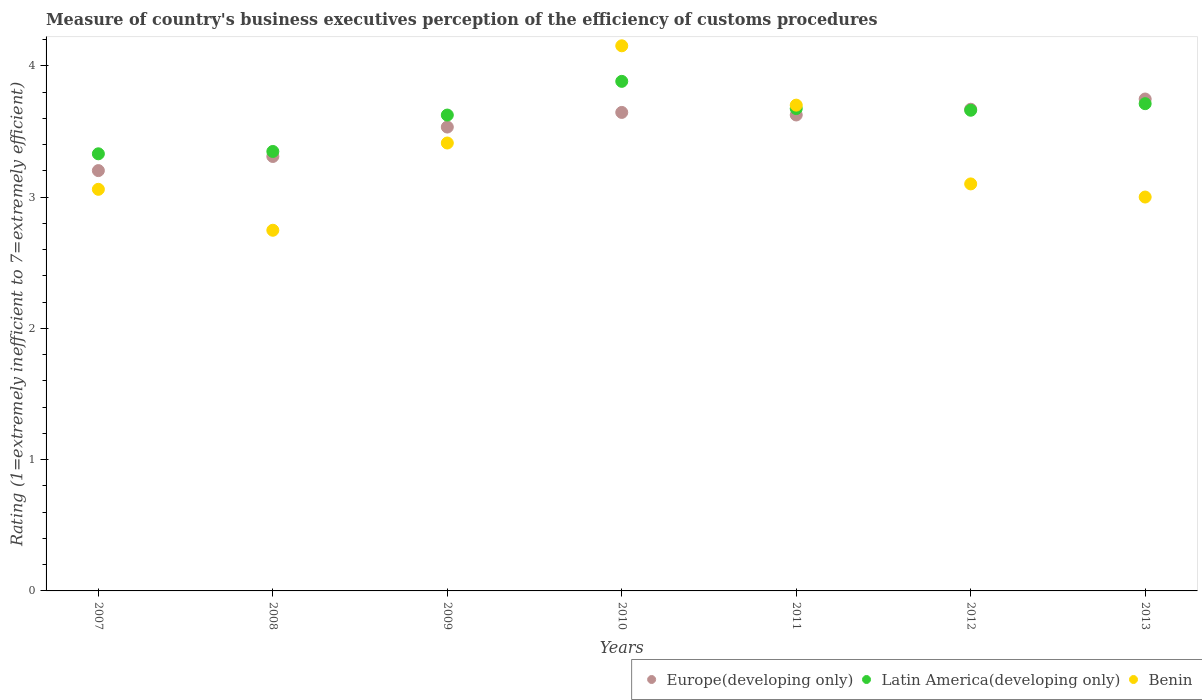How many different coloured dotlines are there?
Your answer should be compact. 3. Is the number of dotlines equal to the number of legend labels?
Give a very brief answer. Yes. What is the rating of the efficiency of customs procedure in Latin America(developing only) in 2013?
Provide a short and direct response. 3.71. Across all years, what is the maximum rating of the efficiency of customs procedure in Europe(developing only)?
Keep it short and to the point. 3.75. Across all years, what is the minimum rating of the efficiency of customs procedure in Benin?
Give a very brief answer. 2.75. In which year was the rating of the efficiency of customs procedure in Europe(developing only) maximum?
Ensure brevity in your answer.  2013. What is the total rating of the efficiency of customs procedure in Benin in the graph?
Your answer should be compact. 23.17. What is the difference between the rating of the efficiency of customs procedure in Europe(developing only) in 2010 and that in 2011?
Ensure brevity in your answer.  0.02. What is the difference between the rating of the efficiency of customs procedure in Latin America(developing only) in 2007 and the rating of the efficiency of customs procedure in Benin in 2012?
Provide a succinct answer. 0.23. What is the average rating of the efficiency of customs procedure in Benin per year?
Your answer should be very brief. 3.31. In the year 2013, what is the difference between the rating of the efficiency of customs procedure in Latin America(developing only) and rating of the efficiency of customs procedure in Europe(developing only)?
Give a very brief answer. -0.04. What is the ratio of the rating of the efficiency of customs procedure in Europe(developing only) in 2011 to that in 2012?
Give a very brief answer. 0.99. Is the rating of the efficiency of customs procedure in Europe(developing only) in 2009 less than that in 2012?
Offer a terse response. Yes. Is the difference between the rating of the efficiency of customs procedure in Latin America(developing only) in 2007 and 2009 greater than the difference between the rating of the efficiency of customs procedure in Europe(developing only) in 2007 and 2009?
Offer a terse response. Yes. What is the difference between the highest and the second highest rating of the efficiency of customs procedure in Latin America(developing only)?
Provide a succinct answer. 0.17. What is the difference between the highest and the lowest rating of the efficiency of customs procedure in Latin America(developing only)?
Your response must be concise. 0.55. In how many years, is the rating of the efficiency of customs procedure in Europe(developing only) greater than the average rating of the efficiency of customs procedure in Europe(developing only) taken over all years?
Provide a succinct answer. 5. Is the sum of the rating of the efficiency of customs procedure in Latin America(developing only) in 2007 and 2012 greater than the maximum rating of the efficiency of customs procedure in Benin across all years?
Your response must be concise. Yes. Is it the case that in every year, the sum of the rating of the efficiency of customs procedure in Benin and rating of the efficiency of customs procedure in Latin America(developing only)  is greater than the rating of the efficiency of customs procedure in Europe(developing only)?
Provide a short and direct response. Yes. How many dotlines are there?
Give a very brief answer. 3. How many years are there in the graph?
Ensure brevity in your answer.  7. Are the values on the major ticks of Y-axis written in scientific E-notation?
Your answer should be very brief. No. Does the graph contain any zero values?
Make the answer very short. No. How are the legend labels stacked?
Provide a succinct answer. Horizontal. What is the title of the graph?
Make the answer very short. Measure of country's business executives perception of the efficiency of customs procedures. Does "Grenada" appear as one of the legend labels in the graph?
Offer a terse response. No. What is the label or title of the Y-axis?
Keep it short and to the point. Rating (1=extremely inefficient to 7=extremely efficient). What is the Rating (1=extremely inefficient to 7=extremely efficient) in Europe(developing only) in 2007?
Your answer should be compact. 3.2. What is the Rating (1=extremely inefficient to 7=extremely efficient) of Latin America(developing only) in 2007?
Your answer should be very brief. 3.33. What is the Rating (1=extremely inefficient to 7=extremely efficient) of Benin in 2007?
Offer a very short reply. 3.06. What is the Rating (1=extremely inefficient to 7=extremely efficient) of Europe(developing only) in 2008?
Give a very brief answer. 3.31. What is the Rating (1=extremely inefficient to 7=extremely efficient) in Latin America(developing only) in 2008?
Your answer should be very brief. 3.35. What is the Rating (1=extremely inefficient to 7=extremely efficient) of Benin in 2008?
Offer a very short reply. 2.75. What is the Rating (1=extremely inefficient to 7=extremely efficient) of Europe(developing only) in 2009?
Offer a terse response. 3.53. What is the Rating (1=extremely inefficient to 7=extremely efficient) of Latin America(developing only) in 2009?
Provide a short and direct response. 3.62. What is the Rating (1=extremely inefficient to 7=extremely efficient) of Benin in 2009?
Offer a terse response. 3.41. What is the Rating (1=extremely inefficient to 7=extremely efficient) of Europe(developing only) in 2010?
Make the answer very short. 3.64. What is the Rating (1=extremely inefficient to 7=extremely efficient) in Latin America(developing only) in 2010?
Offer a terse response. 3.88. What is the Rating (1=extremely inefficient to 7=extremely efficient) in Benin in 2010?
Offer a terse response. 4.15. What is the Rating (1=extremely inefficient to 7=extremely efficient) in Europe(developing only) in 2011?
Offer a very short reply. 3.62. What is the Rating (1=extremely inefficient to 7=extremely efficient) in Latin America(developing only) in 2011?
Your answer should be compact. 3.67. What is the Rating (1=extremely inefficient to 7=extremely efficient) of Benin in 2011?
Ensure brevity in your answer.  3.7. What is the Rating (1=extremely inefficient to 7=extremely efficient) in Europe(developing only) in 2012?
Provide a succinct answer. 3.67. What is the Rating (1=extremely inefficient to 7=extremely efficient) in Latin America(developing only) in 2012?
Provide a succinct answer. 3.66. What is the Rating (1=extremely inefficient to 7=extremely efficient) of Benin in 2012?
Ensure brevity in your answer.  3.1. What is the Rating (1=extremely inefficient to 7=extremely efficient) in Europe(developing only) in 2013?
Keep it short and to the point. 3.75. What is the Rating (1=extremely inefficient to 7=extremely efficient) in Latin America(developing only) in 2013?
Offer a very short reply. 3.71. What is the Rating (1=extremely inefficient to 7=extremely efficient) of Benin in 2013?
Offer a terse response. 3. Across all years, what is the maximum Rating (1=extremely inefficient to 7=extremely efficient) in Europe(developing only)?
Make the answer very short. 3.75. Across all years, what is the maximum Rating (1=extremely inefficient to 7=extremely efficient) in Latin America(developing only)?
Give a very brief answer. 3.88. Across all years, what is the maximum Rating (1=extremely inefficient to 7=extremely efficient) of Benin?
Your answer should be compact. 4.15. Across all years, what is the minimum Rating (1=extremely inefficient to 7=extremely efficient) in Europe(developing only)?
Give a very brief answer. 3.2. Across all years, what is the minimum Rating (1=extremely inefficient to 7=extremely efficient) of Latin America(developing only)?
Keep it short and to the point. 3.33. Across all years, what is the minimum Rating (1=extremely inefficient to 7=extremely efficient) in Benin?
Offer a very short reply. 2.75. What is the total Rating (1=extremely inefficient to 7=extremely efficient) in Europe(developing only) in the graph?
Give a very brief answer. 24.73. What is the total Rating (1=extremely inefficient to 7=extremely efficient) in Latin America(developing only) in the graph?
Keep it short and to the point. 25.23. What is the total Rating (1=extremely inefficient to 7=extremely efficient) in Benin in the graph?
Provide a short and direct response. 23.17. What is the difference between the Rating (1=extremely inefficient to 7=extremely efficient) in Europe(developing only) in 2007 and that in 2008?
Make the answer very short. -0.11. What is the difference between the Rating (1=extremely inefficient to 7=extremely efficient) in Latin America(developing only) in 2007 and that in 2008?
Keep it short and to the point. -0.02. What is the difference between the Rating (1=extremely inefficient to 7=extremely efficient) of Benin in 2007 and that in 2008?
Provide a succinct answer. 0.31. What is the difference between the Rating (1=extremely inefficient to 7=extremely efficient) in Europe(developing only) in 2007 and that in 2009?
Ensure brevity in your answer.  -0.33. What is the difference between the Rating (1=extremely inefficient to 7=extremely efficient) of Latin America(developing only) in 2007 and that in 2009?
Your answer should be very brief. -0.3. What is the difference between the Rating (1=extremely inefficient to 7=extremely efficient) in Benin in 2007 and that in 2009?
Ensure brevity in your answer.  -0.35. What is the difference between the Rating (1=extremely inefficient to 7=extremely efficient) of Europe(developing only) in 2007 and that in 2010?
Make the answer very short. -0.44. What is the difference between the Rating (1=extremely inefficient to 7=extremely efficient) in Latin America(developing only) in 2007 and that in 2010?
Your answer should be very brief. -0.55. What is the difference between the Rating (1=extremely inefficient to 7=extremely efficient) in Benin in 2007 and that in 2010?
Make the answer very short. -1.09. What is the difference between the Rating (1=extremely inefficient to 7=extremely efficient) in Europe(developing only) in 2007 and that in 2011?
Make the answer very short. -0.42. What is the difference between the Rating (1=extremely inefficient to 7=extremely efficient) in Latin America(developing only) in 2007 and that in 2011?
Provide a succinct answer. -0.34. What is the difference between the Rating (1=extremely inefficient to 7=extremely efficient) in Benin in 2007 and that in 2011?
Ensure brevity in your answer.  -0.64. What is the difference between the Rating (1=extremely inefficient to 7=extremely efficient) of Europe(developing only) in 2007 and that in 2012?
Make the answer very short. -0.47. What is the difference between the Rating (1=extremely inefficient to 7=extremely efficient) in Latin America(developing only) in 2007 and that in 2012?
Provide a short and direct response. -0.33. What is the difference between the Rating (1=extremely inefficient to 7=extremely efficient) in Benin in 2007 and that in 2012?
Your response must be concise. -0.04. What is the difference between the Rating (1=extremely inefficient to 7=extremely efficient) in Europe(developing only) in 2007 and that in 2013?
Your answer should be compact. -0.55. What is the difference between the Rating (1=extremely inefficient to 7=extremely efficient) in Latin America(developing only) in 2007 and that in 2013?
Keep it short and to the point. -0.38. What is the difference between the Rating (1=extremely inefficient to 7=extremely efficient) of Benin in 2007 and that in 2013?
Provide a short and direct response. 0.06. What is the difference between the Rating (1=extremely inefficient to 7=extremely efficient) in Europe(developing only) in 2008 and that in 2009?
Give a very brief answer. -0.22. What is the difference between the Rating (1=extremely inefficient to 7=extremely efficient) of Latin America(developing only) in 2008 and that in 2009?
Your answer should be very brief. -0.28. What is the difference between the Rating (1=extremely inefficient to 7=extremely efficient) in Benin in 2008 and that in 2009?
Your response must be concise. -0.66. What is the difference between the Rating (1=extremely inefficient to 7=extremely efficient) in Europe(developing only) in 2008 and that in 2010?
Offer a terse response. -0.34. What is the difference between the Rating (1=extremely inefficient to 7=extremely efficient) of Latin America(developing only) in 2008 and that in 2010?
Provide a short and direct response. -0.53. What is the difference between the Rating (1=extremely inefficient to 7=extremely efficient) in Benin in 2008 and that in 2010?
Give a very brief answer. -1.41. What is the difference between the Rating (1=extremely inefficient to 7=extremely efficient) of Europe(developing only) in 2008 and that in 2011?
Your answer should be compact. -0.32. What is the difference between the Rating (1=extremely inefficient to 7=extremely efficient) of Latin America(developing only) in 2008 and that in 2011?
Provide a short and direct response. -0.33. What is the difference between the Rating (1=extremely inefficient to 7=extremely efficient) in Benin in 2008 and that in 2011?
Offer a terse response. -0.95. What is the difference between the Rating (1=extremely inefficient to 7=extremely efficient) of Europe(developing only) in 2008 and that in 2012?
Give a very brief answer. -0.36. What is the difference between the Rating (1=extremely inefficient to 7=extremely efficient) of Latin America(developing only) in 2008 and that in 2012?
Your response must be concise. -0.31. What is the difference between the Rating (1=extremely inefficient to 7=extremely efficient) of Benin in 2008 and that in 2012?
Keep it short and to the point. -0.35. What is the difference between the Rating (1=extremely inefficient to 7=extremely efficient) of Europe(developing only) in 2008 and that in 2013?
Ensure brevity in your answer.  -0.44. What is the difference between the Rating (1=extremely inefficient to 7=extremely efficient) in Latin America(developing only) in 2008 and that in 2013?
Provide a short and direct response. -0.36. What is the difference between the Rating (1=extremely inefficient to 7=extremely efficient) of Benin in 2008 and that in 2013?
Provide a short and direct response. -0.25. What is the difference between the Rating (1=extremely inefficient to 7=extremely efficient) in Europe(developing only) in 2009 and that in 2010?
Your answer should be very brief. -0.11. What is the difference between the Rating (1=extremely inefficient to 7=extremely efficient) of Latin America(developing only) in 2009 and that in 2010?
Ensure brevity in your answer.  -0.26. What is the difference between the Rating (1=extremely inefficient to 7=extremely efficient) of Benin in 2009 and that in 2010?
Your response must be concise. -0.74. What is the difference between the Rating (1=extremely inefficient to 7=extremely efficient) in Europe(developing only) in 2009 and that in 2011?
Your answer should be compact. -0.09. What is the difference between the Rating (1=extremely inefficient to 7=extremely efficient) of Latin America(developing only) in 2009 and that in 2011?
Your answer should be very brief. -0.05. What is the difference between the Rating (1=extremely inefficient to 7=extremely efficient) of Benin in 2009 and that in 2011?
Keep it short and to the point. -0.29. What is the difference between the Rating (1=extremely inefficient to 7=extremely efficient) of Europe(developing only) in 2009 and that in 2012?
Your answer should be very brief. -0.14. What is the difference between the Rating (1=extremely inefficient to 7=extremely efficient) in Latin America(developing only) in 2009 and that in 2012?
Your response must be concise. -0.04. What is the difference between the Rating (1=extremely inefficient to 7=extremely efficient) in Benin in 2009 and that in 2012?
Your response must be concise. 0.31. What is the difference between the Rating (1=extremely inefficient to 7=extremely efficient) of Europe(developing only) in 2009 and that in 2013?
Keep it short and to the point. -0.21. What is the difference between the Rating (1=extremely inefficient to 7=extremely efficient) of Latin America(developing only) in 2009 and that in 2013?
Provide a short and direct response. -0.09. What is the difference between the Rating (1=extremely inefficient to 7=extremely efficient) of Benin in 2009 and that in 2013?
Offer a terse response. 0.41. What is the difference between the Rating (1=extremely inefficient to 7=extremely efficient) in Europe(developing only) in 2010 and that in 2011?
Your response must be concise. 0.02. What is the difference between the Rating (1=extremely inefficient to 7=extremely efficient) in Latin America(developing only) in 2010 and that in 2011?
Give a very brief answer. 0.21. What is the difference between the Rating (1=extremely inefficient to 7=extremely efficient) in Benin in 2010 and that in 2011?
Ensure brevity in your answer.  0.45. What is the difference between the Rating (1=extremely inefficient to 7=extremely efficient) in Europe(developing only) in 2010 and that in 2012?
Ensure brevity in your answer.  -0.02. What is the difference between the Rating (1=extremely inefficient to 7=extremely efficient) in Latin America(developing only) in 2010 and that in 2012?
Give a very brief answer. 0.22. What is the difference between the Rating (1=extremely inefficient to 7=extremely efficient) in Benin in 2010 and that in 2012?
Provide a short and direct response. 1.05. What is the difference between the Rating (1=extremely inefficient to 7=extremely efficient) of Europe(developing only) in 2010 and that in 2013?
Offer a very short reply. -0.1. What is the difference between the Rating (1=extremely inefficient to 7=extremely efficient) of Latin America(developing only) in 2010 and that in 2013?
Keep it short and to the point. 0.17. What is the difference between the Rating (1=extremely inefficient to 7=extremely efficient) in Benin in 2010 and that in 2013?
Your response must be concise. 1.15. What is the difference between the Rating (1=extremely inefficient to 7=extremely efficient) of Europe(developing only) in 2011 and that in 2012?
Your answer should be compact. -0.04. What is the difference between the Rating (1=extremely inefficient to 7=extremely efficient) of Latin America(developing only) in 2011 and that in 2012?
Provide a succinct answer. 0.01. What is the difference between the Rating (1=extremely inefficient to 7=extremely efficient) in Europe(developing only) in 2011 and that in 2013?
Keep it short and to the point. -0.12. What is the difference between the Rating (1=extremely inefficient to 7=extremely efficient) in Latin America(developing only) in 2011 and that in 2013?
Your answer should be compact. -0.04. What is the difference between the Rating (1=extremely inefficient to 7=extremely efficient) of Benin in 2011 and that in 2013?
Your answer should be very brief. 0.7. What is the difference between the Rating (1=extremely inefficient to 7=extremely efficient) of Europe(developing only) in 2012 and that in 2013?
Ensure brevity in your answer.  -0.08. What is the difference between the Rating (1=extremely inefficient to 7=extremely efficient) in Latin America(developing only) in 2012 and that in 2013?
Make the answer very short. -0.05. What is the difference between the Rating (1=extremely inefficient to 7=extremely efficient) of Benin in 2012 and that in 2013?
Give a very brief answer. 0.1. What is the difference between the Rating (1=extremely inefficient to 7=extremely efficient) of Europe(developing only) in 2007 and the Rating (1=extremely inefficient to 7=extremely efficient) of Latin America(developing only) in 2008?
Your answer should be very brief. -0.15. What is the difference between the Rating (1=extremely inefficient to 7=extremely efficient) in Europe(developing only) in 2007 and the Rating (1=extremely inefficient to 7=extremely efficient) in Benin in 2008?
Offer a terse response. 0.45. What is the difference between the Rating (1=extremely inefficient to 7=extremely efficient) in Latin America(developing only) in 2007 and the Rating (1=extremely inefficient to 7=extremely efficient) in Benin in 2008?
Ensure brevity in your answer.  0.58. What is the difference between the Rating (1=extremely inefficient to 7=extremely efficient) of Europe(developing only) in 2007 and the Rating (1=extremely inefficient to 7=extremely efficient) of Latin America(developing only) in 2009?
Provide a short and direct response. -0.42. What is the difference between the Rating (1=extremely inefficient to 7=extremely efficient) in Europe(developing only) in 2007 and the Rating (1=extremely inefficient to 7=extremely efficient) in Benin in 2009?
Your answer should be compact. -0.21. What is the difference between the Rating (1=extremely inefficient to 7=extremely efficient) in Latin America(developing only) in 2007 and the Rating (1=extremely inefficient to 7=extremely efficient) in Benin in 2009?
Offer a very short reply. -0.08. What is the difference between the Rating (1=extremely inefficient to 7=extremely efficient) in Europe(developing only) in 2007 and the Rating (1=extremely inefficient to 7=extremely efficient) in Latin America(developing only) in 2010?
Make the answer very short. -0.68. What is the difference between the Rating (1=extremely inefficient to 7=extremely efficient) in Europe(developing only) in 2007 and the Rating (1=extremely inefficient to 7=extremely efficient) in Benin in 2010?
Offer a terse response. -0.95. What is the difference between the Rating (1=extremely inefficient to 7=extremely efficient) in Latin America(developing only) in 2007 and the Rating (1=extremely inefficient to 7=extremely efficient) in Benin in 2010?
Your answer should be very brief. -0.82. What is the difference between the Rating (1=extremely inefficient to 7=extremely efficient) in Europe(developing only) in 2007 and the Rating (1=extremely inefficient to 7=extremely efficient) in Latin America(developing only) in 2011?
Provide a succinct answer. -0.47. What is the difference between the Rating (1=extremely inefficient to 7=extremely efficient) of Europe(developing only) in 2007 and the Rating (1=extremely inefficient to 7=extremely efficient) of Benin in 2011?
Make the answer very short. -0.5. What is the difference between the Rating (1=extremely inefficient to 7=extremely efficient) of Latin America(developing only) in 2007 and the Rating (1=extremely inefficient to 7=extremely efficient) of Benin in 2011?
Offer a very short reply. -0.37. What is the difference between the Rating (1=extremely inefficient to 7=extremely efficient) of Europe(developing only) in 2007 and the Rating (1=extremely inefficient to 7=extremely efficient) of Latin America(developing only) in 2012?
Keep it short and to the point. -0.46. What is the difference between the Rating (1=extremely inefficient to 7=extremely efficient) in Europe(developing only) in 2007 and the Rating (1=extremely inefficient to 7=extremely efficient) in Benin in 2012?
Offer a very short reply. 0.1. What is the difference between the Rating (1=extremely inefficient to 7=extremely efficient) in Latin America(developing only) in 2007 and the Rating (1=extremely inefficient to 7=extremely efficient) in Benin in 2012?
Give a very brief answer. 0.23. What is the difference between the Rating (1=extremely inefficient to 7=extremely efficient) in Europe(developing only) in 2007 and the Rating (1=extremely inefficient to 7=extremely efficient) in Latin America(developing only) in 2013?
Ensure brevity in your answer.  -0.51. What is the difference between the Rating (1=extremely inefficient to 7=extremely efficient) in Europe(developing only) in 2007 and the Rating (1=extremely inefficient to 7=extremely efficient) in Benin in 2013?
Offer a terse response. 0.2. What is the difference between the Rating (1=extremely inefficient to 7=extremely efficient) in Latin America(developing only) in 2007 and the Rating (1=extremely inefficient to 7=extremely efficient) in Benin in 2013?
Provide a short and direct response. 0.33. What is the difference between the Rating (1=extremely inefficient to 7=extremely efficient) of Europe(developing only) in 2008 and the Rating (1=extremely inefficient to 7=extremely efficient) of Latin America(developing only) in 2009?
Ensure brevity in your answer.  -0.32. What is the difference between the Rating (1=extremely inefficient to 7=extremely efficient) of Europe(developing only) in 2008 and the Rating (1=extremely inefficient to 7=extremely efficient) of Benin in 2009?
Your answer should be compact. -0.1. What is the difference between the Rating (1=extremely inefficient to 7=extremely efficient) of Latin America(developing only) in 2008 and the Rating (1=extremely inefficient to 7=extremely efficient) of Benin in 2009?
Provide a succinct answer. -0.06. What is the difference between the Rating (1=extremely inefficient to 7=extremely efficient) in Europe(developing only) in 2008 and the Rating (1=extremely inefficient to 7=extremely efficient) in Latin America(developing only) in 2010?
Ensure brevity in your answer.  -0.57. What is the difference between the Rating (1=extremely inefficient to 7=extremely efficient) in Europe(developing only) in 2008 and the Rating (1=extremely inefficient to 7=extremely efficient) in Benin in 2010?
Provide a succinct answer. -0.84. What is the difference between the Rating (1=extremely inefficient to 7=extremely efficient) of Latin America(developing only) in 2008 and the Rating (1=extremely inefficient to 7=extremely efficient) of Benin in 2010?
Ensure brevity in your answer.  -0.8. What is the difference between the Rating (1=extremely inefficient to 7=extremely efficient) of Europe(developing only) in 2008 and the Rating (1=extremely inefficient to 7=extremely efficient) of Latin America(developing only) in 2011?
Your answer should be very brief. -0.36. What is the difference between the Rating (1=extremely inefficient to 7=extremely efficient) in Europe(developing only) in 2008 and the Rating (1=extremely inefficient to 7=extremely efficient) in Benin in 2011?
Make the answer very short. -0.39. What is the difference between the Rating (1=extremely inefficient to 7=extremely efficient) in Latin America(developing only) in 2008 and the Rating (1=extremely inefficient to 7=extremely efficient) in Benin in 2011?
Make the answer very short. -0.35. What is the difference between the Rating (1=extremely inefficient to 7=extremely efficient) of Europe(developing only) in 2008 and the Rating (1=extremely inefficient to 7=extremely efficient) of Latin America(developing only) in 2012?
Your answer should be compact. -0.35. What is the difference between the Rating (1=extremely inefficient to 7=extremely efficient) of Europe(developing only) in 2008 and the Rating (1=extremely inefficient to 7=extremely efficient) of Benin in 2012?
Your answer should be compact. 0.21. What is the difference between the Rating (1=extremely inefficient to 7=extremely efficient) of Latin America(developing only) in 2008 and the Rating (1=extremely inefficient to 7=extremely efficient) of Benin in 2012?
Your answer should be very brief. 0.25. What is the difference between the Rating (1=extremely inefficient to 7=extremely efficient) of Europe(developing only) in 2008 and the Rating (1=extremely inefficient to 7=extremely efficient) of Latin America(developing only) in 2013?
Provide a succinct answer. -0.4. What is the difference between the Rating (1=extremely inefficient to 7=extremely efficient) of Europe(developing only) in 2008 and the Rating (1=extremely inefficient to 7=extremely efficient) of Benin in 2013?
Keep it short and to the point. 0.31. What is the difference between the Rating (1=extremely inefficient to 7=extremely efficient) in Latin America(developing only) in 2008 and the Rating (1=extremely inefficient to 7=extremely efficient) in Benin in 2013?
Provide a short and direct response. 0.35. What is the difference between the Rating (1=extremely inefficient to 7=extremely efficient) in Europe(developing only) in 2009 and the Rating (1=extremely inefficient to 7=extremely efficient) in Latin America(developing only) in 2010?
Provide a succinct answer. -0.35. What is the difference between the Rating (1=extremely inefficient to 7=extremely efficient) in Europe(developing only) in 2009 and the Rating (1=extremely inefficient to 7=extremely efficient) in Benin in 2010?
Offer a very short reply. -0.62. What is the difference between the Rating (1=extremely inefficient to 7=extremely efficient) of Latin America(developing only) in 2009 and the Rating (1=extremely inefficient to 7=extremely efficient) of Benin in 2010?
Keep it short and to the point. -0.53. What is the difference between the Rating (1=extremely inefficient to 7=extremely efficient) of Europe(developing only) in 2009 and the Rating (1=extremely inefficient to 7=extremely efficient) of Latin America(developing only) in 2011?
Your response must be concise. -0.14. What is the difference between the Rating (1=extremely inefficient to 7=extremely efficient) of Europe(developing only) in 2009 and the Rating (1=extremely inefficient to 7=extremely efficient) of Benin in 2011?
Provide a short and direct response. -0.17. What is the difference between the Rating (1=extremely inefficient to 7=extremely efficient) in Latin America(developing only) in 2009 and the Rating (1=extremely inefficient to 7=extremely efficient) in Benin in 2011?
Make the answer very short. -0.08. What is the difference between the Rating (1=extremely inefficient to 7=extremely efficient) in Europe(developing only) in 2009 and the Rating (1=extremely inefficient to 7=extremely efficient) in Latin America(developing only) in 2012?
Give a very brief answer. -0.13. What is the difference between the Rating (1=extremely inefficient to 7=extremely efficient) in Europe(developing only) in 2009 and the Rating (1=extremely inefficient to 7=extremely efficient) in Benin in 2012?
Provide a short and direct response. 0.43. What is the difference between the Rating (1=extremely inefficient to 7=extremely efficient) in Latin America(developing only) in 2009 and the Rating (1=extremely inefficient to 7=extremely efficient) in Benin in 2012?
Keep it short and to the point. 0.52. What is the difference between the Rating (1=extremely inefficient to 7=extremely efficient) of Europe(developing only) in 2009 and the Rating (1=extremely inefficient to 7=extremely efficient) of Latin America(developing only) in 2013?
Ensure brevity in your answer.  -0.18. What is the difference between the Rating (1=extremely inefficient to 7=extremely efficient) of Europe(developing only) in 2009 and the Rating (1=extremely inefficient to 7=extremely efficient) of Benin in 2013?
Make the answer very short. 0.53. What is the difference between the Rating (1=extremely inefficient to 7=extremely efficient) in Latin America(developing only) in 2009 and the Rating (1=extremely inefficient to 7=extremely efficient) in Benin in 2013?
Offer a terse response. 0.62. What is the difference between the Rating (1=extremely inefficient to 7=extremely efficient) in Europe(developing only) in 2010 and the Rating (1=extremely inefficient to 7=extremely efficient) in Latin America(developing only) in 2011?
Make the answer very short. -0.03. What is the difference between the Rating (1=extremely inefficient to 7=extremely efficient) in Europe(developing only) in 2010 and the Rating (1=extremely inefficient to 7=extremely efficient) in Benin in 2011?
Offer a terse response. -0.06. What is the difference between the Rating (1=extremely inefficient to 7=extremely efficient) of Latin America(developing only) in 2010 and the Rating (1=extremely inefficient to 7=extremely efficient) of Benin in 2011?
Give a very brief answer. 0.18. What is the difference between the Rating (1=extremely inefficient to 7=extremely efficient) in Europe(developing only) in 2010 and the Rating (1=extremely inefficient to 7=extremely efficient) in Latin America(developing only) in 2012?
Keep it short and to the point. -0.02. What is the difference between the Rating (1=extremely inefficient to 7=extremely efficient) in Europe(developing only) in 2010 and the Rating (1=extremely inefficient to 7=extremely efficient) in Benin in 2012?
Offer a very short reply. 0.54. What is the difference between the Rating (1=extremely inefficient to 7=extremely efficient) in Latin America(developing only) in 2010 and the Rating (1=extremely inefficient to 7=extremely efficient) in Benin in 2012?
Ensure brevity in your answer.  0.78. What is the difference between the Rating (1=extremely inefficient to 7=extremely efficient) of Europe(developing only) in 2010 and the Rating (1=extremely inefficient to 7=extremely efficient) of Latin America(developing only) in 2013?
Your answer should be compact. -0.07. What is the difference between the Rating (1=extremely inefficient to 7=extremely efficient) of Europe(developing only) in 2010 and the Rating (1=extremely inefficient to 7=extremely efficient) of Benin in 2013?
Your answer should be compact. 0.64. What is the difference between the Rating (1=extremely inefficient to 7=extremely efficient) of Latin America(developing only) in 2010 and the Rating (1=extremely inefficient to 7=extremely efficient) of Benin in 2013?
Offer a very short reply. 0.88. What is the difference between the Rating (1=extremely inefficient to 7=extremely efficient) of Europe(developing only) in 2011 and the Rating (1=extremely inefficient to 7=extremely efficient) of Latin America(developing only) in 2012?
Give a very brief answer. -0.04. What is the difference between the Rating (1=extremely inefficient to 7=extremely efficient) in Europe(developing only) in 2011 and the Rating (1=extremely inefficient to 7=extremely efficient) in Benin in 2012?
Your response must be concise. 0.53. What is the difference between the Rating (1=extremely inefficient to 7=extremely efficient) in Latin America(developing only) in 2011 and the Rating (1=extremely inefficient to 7=extremely efficient) in Benin in 2012?
Provide a short and direct response. 0.57. What is the difference between the Rating (1=extremely inefficient to 7=extremely efficient) of Europe(developing only) in 2011 and the Rating (1=extremely inefficient to 7=extremely efficient) of Latin America(developing only) in 2013?
Keep it short and to the point. -0.09. What is the difference between the Rating (1=extremely inefficient to 7=extremely efficient) in Europe(developing only) in 2011 and the Rating (1=extremely inefficient to 7=extremely efficient) in Benin in 2013?
Offer a very short reply. 0.62. What is the difference between the Rating (1=extremely inefficient to 7=extremely efficient) in Latin America(developing only) in 2011 and the Rating (1=extremely inefficient to 7=extremely efficient) in Benin in 2013?
Offer a very short reply. 0.67. What is the difference between the Rating (1=extremely inefficient to 7=extremely efficient) in Europe(developing only) in 2012 and the Rating (1=extremely inefficient to 7=extremely efficient) in Latin America(developing only) in 2013?
Make the answer very short. -0.04. What is the difference between the Rating (1=extremely inefficient to 7=extremely efficient) in Europe(developing only) in 2012 and the Rating (1=extremely inefficient to 7=extremely efficient) in Benin in 2013?
Your answer should be compact. 0.67. What is the difference between the Rating (1=extremely inefficient to 7=extremely efficient) in Latin America(developing only) in 2012 and the Rating (1=extremely inefficient to 7=extremely efficient) in Benin in 2013?
Provide a succinct answer. 0.66. What is the average Rating (1=extremely inefficient to 7=extremely efficient) in Europe(developing only) per year?
Your response must be concise. 3.53. What is the average Rating (1=extremely inefficient to 7=extremely efficient) of Latin America(developing only) per year?
Give a very brief answer. 3.6. What is the average Rating (1=extremely inefficient to 7=extremely efficient) of Benin per year?
Offer a very short reply. 3.31. In the year 2007, what is the difference between the Rating (1=extremely inefficient to 7=extremely efficient) in Europe(developing only) and Rating (1=extremely inefficient to 7=extremely efficient) in Latin America(developing only)?
Your answer should be very brief. -0.13. In the year 2007, what is the difference between the Rating (1=extremely inefficient to 7=extremely efficient) of Europe(developing only) and Rating (1=extremely inefficient to 7=extremely efficient) of Benin?
Provide a succinct answer. 0.14. In the year 2007, what is the difference between the Rating (1=extremely inefficient to 7=extremely efficient) in Latin America(developing only) and Rating (1=extremely inefficient to 7=extremely efficient) in Benin?
Keep it short and to the point. 0.27. In the year 2008, what is the difference between the Rating (1=extremely inefficient to 7=extremely efficient) in Europe(developing only) and Rating (1=extremely inefficient to 7=extremely efficient) in Latin America(developing only)?
Provide a short and direct response. -0.04. In the year 2008, what is the difference between the Rating (1=extremely inefficient to 7=extremely efficient) of Europe(developing only) and Rating (1=extremely inefficient to 7=extremely efficient) of Benin?
Your answer should be very brief. 0.56. In the year 2008, what is the difference between the Rating (1=extremely inefficient to 7=extremely efficient) of Latin America(developing only) and Rating (1=extremely inefficient to 7=extremely efficient) of Benin?
Your answer should be compact. 0.6. In the year 2009, what is the difference between the Rating (1=extremely inefficient to 7=extremely efficient) in Europe(developing only) and Rating (1=extremely inefficient to 7=extremely efficient) in Latin America(developing only)?
Offer a terse response. -0.09. In the year 2009, what is the difference between the Rating (1=extremely inefficient to 7=extremely efficient) of Europe(developing only) and Rating (1=extremely inefficient to 7=extremely efficient) of Benin?
Offer a very short reply. 0.12. In the year 2009, what is the difference between the Rating (1=extremely inefficient to 7=extremely efficient) of Latin America(developing only) and Rating (1=extremely inefficient to 7=extremely efficient) of Benin?
Provide a short and direct response. 0.21. In the year 2010, what is the difference between the Rating (1=extremely inefficient to 7=extremely efficient) of Europe(developing only) and Rating (1=extremely inefficient to 7=extremely efficient) of Latin America(developing only)?
Give a very brief answer. -0.24. In the year 2010, what is the difference between the Rating (1=extremely inefficient to 7=extremely efficient) in Europe(developing only) and Rating (1=extremely inefficient to 7=extremely efficient) in Benin?
Your answer should be compact. -0.51. In the year 2010, what is the difference between the Rating (1=extremely inefficient to 7=extremely efficient) in Latin America(developing only) and Rating (1=extremely inefficient to 7=extremely efficient) in Benin?
Your answer should be compact. -0.27. In the year 2011, what is the difference between the Rating (1=extremely inefficient to 7=extremely efficient) in Europe(developing only) and Rating (1=extremely inefficient to 7=extremely efficient) in Latin America(developing only)?
Offer a very short reply. -0.05. In the year 2011, what is the difference between the Rating (1=extremely inefficient to 7=extremely efficient) of Europe(developing only) and Rating (1=extremely inefficient to 7=extremely efficient) of Benin?
Provide a succinct answer. -0.07. In the year 2011, what is the difference between the Rating (1=extremely inefficient to 7=extremely efficient) in Latin America(developing only) and Rating (1=extremely inefficient to 7=extremely efficient) in Benin?
Offer a very short reply. -0.03. In the year 2012, what is the difference between the Rating (1=extremely inefficient to 7=extremely efficient) of Europe(developing only) and Rating (1=extremely inefficient to 7=extremely efficient) of Latin America(developing only)?
Provide a succinct answer. 0.01. In the year 2012, what is the difference between the Rating (1=extremely inefficient to 7=extremely efficient) in Europe(developing only) and Rating (1=extremely inefficient to 7=extremely efficient) in Benin?
Keep it short and to the point. 0.57. In the year 2012, what is the difference between the Rating (1=extremely inefficient to 7=extremely efficient) of Latin America(developing only) and Rating (1=extremely inefficient to 7=extremely efficient) of Benin?
Make the answer very short. 0.56. In the year 2013, what is the difference between the Rating (1=extremely inefficient to 7=extremely efficient) of Europe(developing only) and Rating (1=extremely inefficient to 7=extremely efficient) of Latin America(developing only)?
Offer a terse response. 0.04. In the year 2013, what is the difference between the Rating (1=extremely inefficient to 7=extremely efficient) of Europe(developing only) and Rating (1=extremely inefficient to 7=extremely efficient) of Benin?
Your answer should be very brief. 0.75. In the year 2013, what is the difference between the Rating (1=extremely inefficient to 7=extremely efficient) in Latin America(developing only) and Rating (1=extremely inefficient to 7=extremely efficient) in Benin?
Your response must be concise. 0.71. What is the ratio of the Rating (1=extremely inefficient to 7=extremely efficient) of Europe(developing only) in 2007 to that in 2008?
Provide a succinct answer. 0.97. What is the ratio of the Rating (1=extremely inefficient to 7=extremely efficient) in Latin America(developing only) in 2007 to that in 2008?
Your response must be concise. 0.99. What is the ratio of the Rating (1=extremely inefficient to 7=extremely efficient) in Benin in 2007 to that in 2008?
Your answer should be compact. 1.11. What is the ratio of the Rating (1=extremely inefficient to 7=extremely efficient) in Europe(developing only) in 2007 to that in 2009?
Your answer should be very brief. 0.91. What is the ratio of the Rating (1=extremely inefficient to 7=extremely efficient) in Latin America(developing only) in 2007 to that in 2009?
Your response must be concise. 0.92. What is the ratio of the Rating (1=extremely inefficient to 7=extremely efficient) in Benin in 2007 to that in 2009?
Make the answer very short. 0.9. What is the ratio of the Rating (1=extremely inefficient to 7=extremely efficient) in Europe(developing only) in 2007 to that in 2010?
Provide a succinct answer. 0.88. What is the ratio of the Rating (1=extremely inefficient to 7=extremely efficient) of Latin America(developing only) in 2007 to that in 2010?
Provide a short and direct response. 0.86. What is the ratio of the Rating (1=extremely inefficient to 7=extremely efficient) in Benin in 2007 to that in 2010?
Keep it short and to the point. 0.74. What is the ratio of the Rating (1=extremely inefficient to 7=extremely efficient) of Europe(developing only) in 2007 to that in 2011?
Offer a terse response. 0.88. What is the ratio of the Rating (1=extremely inefficient to 7=extremely efficient) in Latin America(developing only) in 2007 to that in 2011?
Offer a terse response. 0.91. What is the ratio of the Rating (1=extremely inefficient to 7=extremely efficient) of Benin in 2007 to that in 2011?
Ensure brevity in your answer.  0.83. What is the ratio of the Rating (1=extremely inefficient to 7=extremely efficient) of Europe(developing only) in 2007 to that in 2012?
Offer a terse response. 0.87. What is the ratio of the Rating (1=extremely inefficient to 7=extremely efficient) of Latin America(developing only) in 2007 to that in 2012?
Provide a succinct answer. 0.91. What is the ratio of the Rating (1=extremely inefficient to 7=extremely efficient) in Benin in 2007 to that in 2012?
Offer a terse response. 0.99. What is the ratio of the Rating (1=extremely inefficient to 7=extremely efficient) in Europe(developing only) in 2007 to that in 2013?
Offer a terse response. 0.85. What is the ratio of the Rating (1=extremely inefficient to 7=extremely efficient) in Latin America(developing only) in 2007 to that in 2013?
Make the answer very short. 0.9. What is the ratio of the Rating (1=extremely inefficient to 7=extremely efficient) of Benin in 2007 to that in 2013?
Provide a short and direct response. 1.02. What is the ratio of the Rating (1=extremely inefficient to 7=extremely efficient) in Europe(developing only) in 2008 to that in 2009?
Offer a very short reply. 0.94. What is the ratio of the Rating (1=extremely inefficient to 7=extremely efficient) of Latin America(developing only) in 2008 to that in 2009?
Your response must be concise. 0.92. What is the ratio of the Rating (1=extremely inefficient to 7=extremely efficient) in Benin in 2008 to that in 2009?
Keep it short and to the point. 0.81. What is the ratio of the Rating (1=extremely inefficient to 7=extremely efficient) in Europe(developing only) in 2008 to that in 2010?
Your response must be concise. 0.91. What is the ratio of the Rating (1=extremely inefficient to 7=extremely efficient) of Latin America(developing only) in 2008 to that in 2010?
Your response must be concise. 0.86. What is the ratio of the Rating (1=extremely inefficient to 7=extremely efficient) in Benin in 2008 to that in 2010?
Your answer should be very brief. 0.66. What is the ratio of the Rating (1=extremely inefficient to 7=extremely efficient) of Europe(developing only) in 2008 to that in 2011?
Ensure brevity in your answer.  0.91. What is the ratio of the Rating (1=extremely inefficient to 7=extremely efficient) in Latin America(developing only) in 2008 to that in 2011?
Ensure brevity in your answer.  0.91. What is the ratio of the Rating (1=extremely inefficient to 7=extremely efficient) in Benin in 2008 to that in 2011?
Keep it short and to the point. 0.74. What is the ratio of the Rating (1=extremely inefficient to 7=extremely efficient) of Europe(developing only) in 2008 to that in 2012?
Your answer should be compact. 0.9. What is the ratio of the Rating (1=extremely inefficient to 7=extremely efficient) in Latin America(developing only) in 2008 to that in 2012?
Offer a very short reply. 0.91. What is the ratio of the Rating (1=extremely inefficient to 7=extremely efficient) of Benin in 2008 to that in 2012?
Provide a short and direct response. 0.89. What is the ratio of the Rating (1=extremely inefficient to 7=extremely efficient) of Europe(developing only) in 2008 to that in 2013?
Make the answer very short. 0.88. What is the ratio of the Rating (1=extremely inefficient to 7=extremely efficient) of Latin America(developing only) in 2008 to that in 2013?
Provide a short and direct response. 0.9. What is the ratio of the Rating (1=extremely inefficient to 7=extremely efficient) in Benin in 2008 to that in 2013?
Your answer should be very brief. 0.92. What is the ratio of the Rating (1=extremely inefficient to 7=extremely efficient) in Europe(developing only) in 2009 to that in 2010?
Ensure brevity in your answer.  0.97. What is the ratio of the Rating (1=extremely inefficient to 7=extremely efficient) in Latin America(developing only) in 2009 to that in 2010?
Provide a short and direct response. 0.93. What is the ratio of the Rating (1=extremely inefficient to 7=extremely efficient) of Benin in 2009 to that in 2010?
Keep it short and to the point. 0.82. What is the ratio of the Rating (1=extremely inefficient to 7=extremely efficient) of Europe(developing only) in 2009 to that in 2011?
Your answer should be very brief. 0.97. What is the ratio of the Rating (1=extremely inefficient to 7=extremely efficient) in Latin America(developing only) in 2009 to that in 2011?
Offer a very short reply. 0.99. What is the ratio of the Rating (1=extremely inefficient to 7=extremely efficient) of Benin in 2009 to that in 2011?
Provide a succinct answer. 0.92. What is the ratio of the Rating (1=extremely inefficient to 7=extremely efficient) of Europe(developing only) in 2009 to that in 2012?
Ensure brevity in your answer.  0.96. What is the ratio of the Rating (1=extremely inefficient to 7=extremely efficient) in Latin America(developing only) in 2009 to that in 2012?
Give a very brief answer. 0.99. What is the ratio of the Rating (1=extremely inefficient to 7=extremely efficient) in Benin in 2009 to that in 2012?
Provide a short and direct response. 1.1. What is the ratio of the Rating (1=extremely inefficient to 7=extremely efficient) in Europe(developing only) in 2009 to that in 2013?
Give a very brief answer. 0.94. What is the ratio of the Rating (1=extremely inefficient to 7=extremely efficient) in Latin America(developing only) in 2009 to that in 2013?
Ensure brevity in your answer.  0.98. What is the ratio of the Rating (1=extremely inefficient to 7=extremely efficient) of Benin in 2009 to that in 2013?
Your response must be concise. 1.14. What is the ratio of the Rating (1=extremely inefficient to 7=extremely efficient) in Europe(developing only) in 2010 to that in 2011?
Offer a very short reply. 1.01. What is the ratio of the Rating (1=extremely inefficient to 7=extremely efficient) of Latin America(developing only) in 2010 to that in 2011?
Offer a very short reply. 1.06. What is the ratio of the Rating (1=extremely inefficient to 7=extremely efficient) of Benin in 2010 to that in 2011?
Your response must be concise. 1.12. What is the ratio of the Rating (1=extremely inefficient to 7=extremely efficient) in Europe(developing only) in 2010 to that in 2012?
Your answer should be very brief. 0.99. What is the ratio of the Rating (1=extremely inefficient to 7=extremely efficient) in Latin America(developing only) in 2010 to that in 2012?
Offer a very short reply. 1.06. What is the ratio of the Rating (1=extremely inefficient to 7=extremely efficient) in Benin in 2010 to that in 2012?
Make the answer very short. 1.34. What is the ratio of the Rating (1=extremely inefficient to 7=extremely efficient) of Europe(developing only) in 2010 to that in 2013?
Provide a short and direct response. 0.97. What is the ratio of the Rating (1=extremely inefficient to 7=extremely efficient) of Latin America(developing only) in 2010 to that in 2013?
Your answer should be compact. 1.05. What is the ratio of the Rating (1=extremely inefficient to 7=extremely efficient) of Benin in 2010 to that in 2013?
Your response must be concise. 1.38. What is the ratio of the Rating (1=extremely inefficient to 7=extremely efficient) of Benin in 2011 to that in 2012?
Give a very brief answer. 1.19. What is the ratio of the Rating (1=extremely inefficient to 7=extremely efficient) in Europe(developing only) in 2011 to that in 2013?
Offer a terse response. 0.97. What is the ratio of the Rating (1=extremely inefficient to 7=extremely efficient) of Latin America(developing only) in 2011 to that in 2013?
Give a very brief answer. 0.99. What is the ratio of the Rating (1=extremely inefficient to 7=extremely efficient) in Benin in 2011 to that in 2013?
Provide a short and direct response. 1.23. What is the ratio of the Rating (1=extremely inefficient to 7=extremely efficient) in Europe(developing only) in 2012 to that in 2013?
Provide a short and direct response. 0.98. What is the ratio of the Rating (1=extremely inefficient to 7=extremely efficient) of Latin America(developing only) in 2012 to that in 2013?
Your response must be concise. 0.99. What is the ratio of the Rating (1=extremely inefficient to 7=extremely efficient) in Benin in 2012 to that in 2013?
Your answer should be compact. 1.03. What is the difference between the highest and the second highest Rating (1=extremely inefficient to 7=extremely efficient) in Europe(developing only)?
Keep it short and to the point. 0.08. What is the difference between the highest and the second highest Rating (1=extremely inefficient to 7=extremely efficient) in Latin America(developing only)?
Your response must be concise. 0.17. What is the difference between the highest and the second highest Rating (1=extremely inefficient to 7=extremely efficient) of Benin?
Give a very brief answer. 0.45. What is the difference between the highest and the lowest Rating (1=extremely inefficient to 7=extremely efficient) in Europe(developing only)?
Ensure brevity in your answer.  0.55. What is the difference between the highest and the lowest Rating (1=extremely inefficient to 7=extremely efficient) of Latin America(developing only)?
Your response must be concise. 0.55. What is the difference between the highest and the lowest Rating (1=extremely inefficient to 7=extremely efficient) of Benin?
Your answer should be very brief. 1.41. 